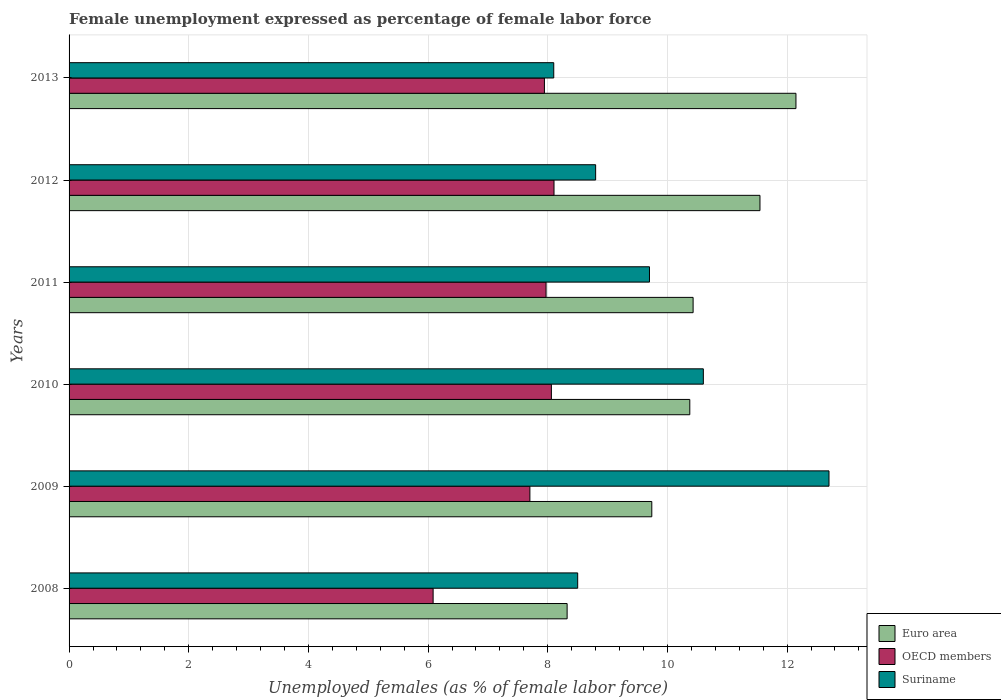Are the number of bars on each tick of the Y-axis equal?
Provide a short and direct response. Yes. How many bars are there on the 3rd tick from the top?
Give a very brief answer. 3. How many bars are there on the 2nd tick from the bottom?
Provide a short and direct response. 3. What is the unemployment in females in in Suriname in 2010?
Your answer should be very brief. 10.6. Across all years, what is the maximum unemployment in females in in OECD members?
Offer a very short reply. 8.1. Across all years, what is the minimum unemployment in females in in Euro area?
Ensure brevity in your answer.  8.32. In which year was the unemployment in females in in Euro area maximum?
Offer a very short reply. 2013. In which year was the unemployment in females in in OECD members minimum?
Keep it short and to the point. 2008. What is the total unemployment in females in in OECD members in the graph?
Offer a terse response. 45.87. What is the difference between the unemployment in females in in Suriname in 2010 and that in 2011?
Keep it short and to the point. 0.9. What is the difference between the unemployment in females in in Suriname in 2010 and the unemployment in females in in OECD members in 2011?
Keep it short and to the point. 2.63. What is the average unemployment in females in in Euro area per year?
Offer a terse response. 10.43. In the year 2008, what is the difference between the unemployment in females in in OECD members and unemployment in females in in Suriname?
Offer a terse response. -2.42. What is the ratio of the unemployment in females in in Euro area in 2011 to that in 2013?
Provide a succinct answer. 0.86. Is the unemployment in females in in Suriname in 2009 less than that in 2010?
Keep it short and to the point. No. What is the difference between the highest and the second highest unemployment in females in in OECD members?
Your answer should be very brief. 0.04. What is the difference between the highest and the lowest unemployment in females in in OECD members?
Keep it short and to the point. 2.02. What does the 1st bar from the top in 2008 represents?
Ensure brevity in your answer.  Suriname. Is it the case that in every year, the sum of the unemployment in females in in Suriname and unemployment in females in in OECD members is greater than the unemployment in females in in Euro area?
Offer a terse response. Yes. Are all the bars in the graph horizontal?
Give a very brief answer. Yes. How many years are there in the graph?
Your response must be concise. 6. Are the values on the major ticks of X-axis written in scientific E-notation?
Make the answer very short. No. Does the graph contain any zero values?
Give a very brief answer. No. How many legend labels are there?
Provide a succinct answer. 3. How are the legend labels stacked?
Make the answer very short. Vertical. What is the title of the graph?
Offer a very short reply. Female unemployment expressed as percentage of female labor force. What is the label or title of the X-axis?
Your response must be concise. Unemployed females (as % of female labor force). What is the Unemployed females (as % of female labor force) in Euro area in 2008?
Your answer should be compact. 8.32. What is the Unemployed females (as % of female labor force) of OECD members in 2008?
Give a very brief answer. 6.08. What is the Unemployed females (as % of female labor force) of Suriname in 2008?
Your answer should be very brief. 8.5. What is the Unemployed females (as % of female labor force) in Euro area in 2009?
Offer a very short reply. 9.74. What is the Unemployed females (as % of female labor force) in OECD members in 2009?
Ensure brevity in your answer.  7.7. What is the Unemployed females (as % of female labor force) of Suriname in 2009?
Your response must be concise. 12.7. What is the Unemployed females (as % of female labor force) in Euro area in 2010?
Offer a terse response. 10.37. What is the Unemployed females (as % of female labor force) in OECD members in 2010?
Your response must be concise. 8.06. What is the Unemployed females (as % of female labor force) of Suriname in 2010?
Offer a very short reply. 10.6. What is the Unemployed females (as % of female labor force) of Euro area in 2011?
Make the answer very short. 10.43. What is the Unemployed females (as % of female labor force) of OECD members in 2011?
Provide a short and direct response. 7.97. What is the Unemployed females (as % of female labor force) of Suriname in 2011?
Your answer should be very brief. 9.7. What is the Unemployed females (as % of female labor force) in Euro area in 2012?
Your answer should be very brief. 11.55. What is the Unemployed females (as % of female labor force) of OECD members in 2012?
Keep it short and to the point. 8.1. What is the Unemployed females (as % of female labor force) in Suriname in 2012?
Your response must be concise. 8.8. What is the Unemployed females (as % of female labor force) in Euro area in 2013?
Provide a succinct answer. 12.15. What is the Unemployed females (as % of female labor force) of OECD members in 2013?
Your response must be concise. 7.94. What is the Unemployed females (as % of female labor force) in Suriname in 2013?
Provide a short and direct response. 8.1. Across all years, what is the maximum Unemployed females (as % of female labor force) in Euro area?
Offer a very short reply. 12.15. Across all years, what is the maximum Unemployed females (as % of female labor force) of OECD members?
Make the answer very short. 8.1. Across all years, what is the maximum Unemployed females (as % of female labor force) of Suriname?
Your response must be concise. 12.7. Across all years, what is the minimum Unemployed females (as % of female labor force) of Euro area?
Ensure brevity in your answer.  8.32. Across all years, what is the minimum Unemployed females (as % of female labor force) in OECD members?
Your answer should be compact. 6.08. Across all years, what is the minimum Unemployed females (as % of female labor force) in Suriname?
Your answer should be compact. 8.1. What is the total Unemployed females (as % of female labor force) of Euro area in the graph?
Offer a terse response. 62.56. What is the total Unemployed females (as % of female labor force) in OECD members in the graph?
Offer a very short reply. 45.87. What is the total Unemployed females (as % of female labor force) in Suriname in the graph?
Offer a very short reply. 58.4. What is the difference between the Unemployed females (as % of female labor force) in Euro area in 2008 and that in 2009?
Provide a succinct answer. -1.42. What is the difference between the Unemployed females (as % of female labor force) in OECD members in 2008 and that in 2009?
Your answer should be compact. -1.62. What is the difference between the Unemployed females (as % of female labor force) of Suriname in 2008 and that in 2009?
Your response must be concise. -4.2. What is the difference between the Unemployed females (as % of female labor force) in Euro area in 2008 and that in 2010?
Provide a short and direct response. -2.05. What is the difference between the Unemployed females (as % of female labor force) in OECD members in 2008 and that in 2010?
Your response must be concise. -1.98. What is the difference between the Unemployed females (as % of female labor force) in Euro area in 2008 and that in 2011?
Offer a very short reply. -2.11. What is the difference between the Unemployed females (as % of female labor force) of OECD members in 2008 and that in 2011?
Your response must be concise. -1.89. What is the difference between the Unemployed females (as % of female labor force) in Suriname in 2008 and that in 2011?
Offer a very short reply. -1.2. What is the difference between the Unemployed females (as % of female labor force) of Euro area in 2008 and that in 2012?
Your response must be concise. -3.22. What is the difference between the Unemployed females (as % of female labor force) in OECD members in 2008 and that in 2012?
Offer a terse response. -2.02. What is the difference between the Unemployed females (as % of female labor force) in Suriname in 2008 and that in 2012?
Keep it short and to the point. -0.3. What is the difference between the Unemployed females (as % of female labor force) in Euro area in 2008 and that in 2013?
Offer a terse response. -3.82. What is the difference between the Unemployed females (as % of female labor force) in OECD members in 2008 and that in 2013?
Ensure brevity in your answer.  -1.86. What is the difference between the Unemployed females (as % of female labor force) in Suriname in 2008 and that in 2013?
Provide a short and direct response. 0.4. What is the difference between the Unemployed females (as % of female labor force) in Euro area in 2009 and that in 2010?
Provide a short and direct response. -0.63. What is the difference between the Unemployed females (as % of female labor force) in OECD members in 2009 and that in 2010?
Ensure brevity in your answer.  -0.36. What is the difference between the Unemployed females (as % of female labor force) in Euro area in 2009 and that in 2011?
Ensure brevity in your answer.  -0.69. What is the difference between the Unemployed females (as % of female labor force) in OECD members in 2009 and that in 2011?
Keep it short and to the point. -0.27. What is the difference between the Unemployed females (as % of female labor force) in Suriname in 2009 and that in 2011?
Keep it short and to the point. 3. What is the difference between the Unemployed females (as % of female labor force) of Euro area in 2009 and that in 2012?
Provide a short and direct response. -1.81. What is the difference between the Unemployed females (as % of female labor force) of OECD members in 2009 and that in 2012?
Your response must be concise. -0.4. What is the difference between the Unemployed females (as % of female labor force) of Euro area in 2009 and that in 2013?
Offer a very short reply. -2.41. What is the difference between the Unemployed females (as % of female labor force) in OECD members in 2009 and that in 2013?
Keep it short and to the point. -0.24. What is the difference between the Unemployed females (as % of female labor force) of Euro area in 2010 and that in 2011?
Offer a terse response. -0.06. What is the difference between the Unemployed females (as % of female labor force) of OECD members in 2010 and that in 2011?
Your answer should be compact. 0.09. What is the difference between the Unemployed females (as % of female labor force) in Euro area in 2010 and that in 2012?
Provide a short and direct response. -1.17. What is the difference between the Unemployed females (as % of female labor force) in OECD members in 2010 and that in 2012?
Give a very brief answer. -0.04. What is the difference between the Unemployed females (as % of female labor force) of Suriname in 2010 and that in 2012?
Ensure brevity in your answer.  1.8. What is the difference between the Unemployed females (as % of female labor force) of Euro area in 2010 and that in 2013?
Ensure brevity in your answer.  -1.77. What is the difference between the Unemployed females (as % of female labor force) in OECD members in 2010 and that in 2013?
Your response must be concise. 0.12. What is the difference between the Unemployed females (as % of female labor force) in Suriname in 2010 and that in 2013?
Keep it short and to the point. 2.5. What is the difference between the Unemployed females (as % of female labor force) of Euro area in 2011 and that in 2012?
Offer a very short reply. -1.12. What is the difference between the Unemployed females (as % of female labor force) of OECD members in 2011 and that in 2012?
Your response must be concise. -0.13. What is the difference between the Unemployed females (as % of female labor force) in Suriname in 2011 and that in 2012?
Provide a succinct answer. 0.9. What is the difference between the Unemployed females (as % of female labor force) of Euro area in 2011 and that in 2013?
Make the answer very short. -1.72. What is the difference between the Unemployed females (as % of female labor force) of OECD members in 2011 and that in 2013?
Make the answer very short. 0.03. What is the difference between the Unemployed females (as % of female labor force) in Euro area in 2012 and that in 2013?
Keep it short and to the point. -0.6. What is the difference between the Unemployed females (as % of female labor force) of OECD members in 2012 and that in 2013?
Make the answer very short. 0.16. What is the difference between the Unemployed females (as % of female labor force) in Euro area in 2008 and the Unemployed females (as % of female labor force) in OECD members in 2009?
Provide a succinct answer. 0.62. What is the difference between the Unemployed females (as % of female labor force) of Euro area in 2008 and the Unemployed females (as % of female labor force) of Suriname in 2009?
Your answer should be very brief. -4.38. What is the difference between the Unemployed females (as % of female labor force) in OECD members in 2008 and the Unemployed females (as % of female labor force) in Suriname in 2009?
Ensure brevity in your answer.  -6.62. What is the difference between the Unemployed females (as % of female labor force) in Euro area in 2008 and the Unemployed females (as % of female labor force) in OECD members in 2010?
Keep it short and to the point. 0.26. What is the difference between the Unemployed females (as % of female labor force) in Euro area in 2008 and the Unemployed females (as % of female labor force) in Suriname in 2010?
Your answer should be very brief. -2.28. What is the difference between the Unemployed females (as % of female labor force) of OECD members in 2008 and the Unemployed females (as % of female labor force) of Suriname in 2010?
Provide a succinct answer. -4.52. What is the difference between the Unemployed females (as % of female labor force) of Euro area in 2008 and the Unemployed females (as % of female labor force) of OECD members in 2011?
Offer a very short reply. 0.35. What is the difference between the Unemployed females (as % of female labor force) of Euro area in 2008 and the Unemployed females (as % of female labor force) of Suriname in 2011?
Provide a short and direct response. -1.38. What is the difference between the Unemployed females (as % of female labor force) in OECD members in 2008 and the Unemployed females (as % of female labor force) in Suriname in 2011?
Ensure brevity in your answer.  -3.62. What is the difference between the Unemployed females (as % of female labor force) in Euro area in 2008 and the Unemployed females (as % of female labor force) in OECD members in 2012?
Your answer should be very brief. 0.22. What is the difference between the Unemployed females (as % of female labor force) in Euro area in 2008 and the Unemployed females (as % of female labor force) in Suriname in 2012?
Offer a very short reply. -0.48. What is the difference between the Unemployed females (as % of female labor force) in OECD members in 2008 and the Unemployed females (as % of female labor force) in Suriname in 2012?
Provide a succinct answer. -2.72. What is the difference between the Unemployed females (as % of female labor force) in Euro area in 2008 and the Unemployed females (as % of female labor force) in OECD members in 2013?
Your response must be concise. 0.38. What is the difference between the Unemployed females (as % of female labor force) of Euro area in 2008 and the Unemployed females (as % of female labor force) of Suriname in 2013?
Offer a very short reply. 0.22. What is the difference between the Unemployed females (as % of female labor force) of OECD members in 2008 and the Unemployed females (as % of female labor force) of Suriname in 2013?
Offer a terse response. -2.02. What is the difference between the Unemployed females (as % of female labor force) in Euro area in 2009 and the Unemployed females (as % of female labor force) in OECD members in 2010?
Offer a terse response. 1.68. What is the difference between the Unemployed females (as % of female labor force) of Euro area in 2009 and the Unemployed females (as % of female labor force) of Suriname in 2010?
Your answer should be very brief. -0.86. What is the difference between the Unemployed females (as % of female labor force) of OECD members in 2009 and the Unemployed females (as % of female labor force) of Suriname in 2010?
Offer a very short reply. -2.9. What is the difference between the Unemployed females (as % of female labor force) in Euro area in 2009 and the Unemployed females (as % of female labor force) in OECD members in 2011?
Give a very brief answer. 1.77. What is the difference between the Unemployed females (as % of female labor force) of Euro area in 2009 and the Unemployed females (as % of female labor force) of Suriname in 2011?
Provide a short and direct response. 0.04. What is the difference between the Unemployed females (as % of female labor force) in OECD members in 2009 and the Unemployed females (as % of female labor force) in Suriname in 2011?
Provide a short and direct response. -2. What is the difference between the Unemployed females (as % of female labor force) of Euro area in 2009 and the Unemployed females (as % of female labor force) of OECD members in 2012?
Ensure brevity in your answer.  1.63. What is the difference between the Unemployed females (as % of female labor force) of Euro area in 2009 and the Unemployed females (as % of female labor force) of Suriname in 2012?
Keep it short and to the point. 0.94. What is the difference between the Unemployed females (as % of female labor force) in OECD members in 2009 and the Unemployed females (as % of female labor force) in Suriname in 2012?
Ensure brevity in your answer.  -1.1. What is the difference between the Unemployed females (as % of female labor force) of Euro area in 2009 and the Unemployed females (as % of female labor force) of OECD members in 2013?
Provide a succinct answer. 1.79. What is the difference between the Unemployed females (as % of female labor force) of Euro area in 2009 and the Unemployed females (as % of female labor force) of Suriname in 2013?
Provide a short and direct response. 1.64. What is the difference between the Unemployed females (as % of female labor force) of OECD members in 2009 and the Unemployed females (as % of female labor force) of Suriname in 2013?
Give a very brief answer. -0.4. What is the difference between the Unemployed females (as % of female labor force) in Euro area in 2010 and the Unemployed females (as % of female labor force) in OECD members in 2011?
Your response must be concise. 2.4. What is the difference between the Unemployed females (as % of female labor force) in Euro area in 2010 and the Unemployed females (as % of female labor force) in Suriname in 2011?
Offer a terse response. 0.67. What is the difference between the Unemployed females (as % of female labor force) of OECD members in 2010 and the Unemployed females (as % of female labor force) of Suriname in 2011?
Offer a very short reply. -1.64. What is the difference between the Unemployed females (as % of female labor force) of Euro area in 2010 and the Unemployed females (as % of female labor force) of OECD members in 2012?
Keep it short and to the point. 2.27. What is the difference between the Unemployed females (as % of female labor force) in Euro area in 2010 and the Unemployed females (as % of female labor force) in Suriname in 2012?
Your answer should be very brief. 1.57. What is the difference between the Unemployed females (as % of female labor force) of OECD members in 2010 and the Unemployed females (as % of female labor force) of Suriname in 2012?
Offer a very short reply. -0.74. What is the difference between the Unemployed females (as % of female labor force) in Euro area in 2010 and the Unemployed females (as % of female labor force) in OECD members in 2013?
Ensure brevity in your answer.  2.43. What is the difference between the Unemployed females (as % of female labor force) of Euro area in 2010 and the Unemployed females (as % of female labor force) of Suriname in 2013?
Your answer should be very brief. 2.27. What is the difference between the Unemployed females (as % of female labor force) in OECD members in 2010 and the Unemployed females (as % of female labor force) in Suriname in 2013?
Offer a very short reply. -0.04. What is the difference between the Unemployed females (as % of female labor force) of Euro area in 2011 and the Unemployed females (as % of female labor force) of OECD members in 2012?
Your answer should be compact. 2.32. What is the difference between the Unemployed females (as % of female labor force) of Euro area in 2011 and the Unemployed females (as % of female labor force) of Suriname in 2012?
Your answer should be compact. 1.63. What is the difference between the Unemployed females (as % of female labor force) of OECD members in 2011 and the Unemployed females (as % of female labor force) of Suriname in 2012?
Your answer should be compact. -0.83. What is the difference between the Unemployed females (as % of female labor force) in Euro area in 2011 and the Unemployed females (as % of female labor force) in OECD members in 2013?
Make the answer very short. 2.48. What is the difference between the Unemployed females (as % of female labor force) of Euro area in 2011 and the Unemployed females (as % of female labor force) of Suriname in 2013?
Your answer should be compact. 2.33. What is the difference between the Unemployed females (as % of female labor force) in OECD members in 2011 and the Unemployed females (as % of female labor force) in Suriname in 2013?
Keep it short and to the point. -0.13. What is the difference between the Unemployed females (as % of female labor force) of Euro area in 2012 and the Unemployed females (as % of female labor force) of OECD members in 2013?
Your answer should be compact. 3.6. What is the difference between the Unemployed females (as % of female labor force) in Euro area in 2012 and the Unemployed females (as % of female labor force) in Suriname in 2013?
Your response must be concise. 3.45. What is the difference between the Unemployed females (as % of female labor force) of OECD members in 2012 and the Unemployed females (as % of female labor force) of Suriname in 2013?
Offer a very short reply. 0. What is the average Unemployed females (as % of female labor force) of Euro area per year?
Offer a terse response. 10.43. What is the average Unemployed females (as % of female labor force) of OECD members per year?
Offer a very short reply. 7.64. What is the average Unemployed females (as % of female labor force) in Suriname per year?
Make the answer very short. 9.73. In the year 2008, what is the difference between the Unemployed females (as % of female labor force) of Euro area and Unemployed females (as % of female labor force) of OECD members?
Give a very brief answer. 2.24. In the year 2008, what is the difference between the Unemployed females (as % of female labor force) of Euro area and Unemployed females (as % of female labor force) of Suriname?
Offer a terse response. -0.18. In the year 2008, what is the difference between the Unemployed females (as % of female labor force) in OECD members and Unemployed females (as % of female labor force) in Suriname?
Offer a very short reply. -2.42. In the year 2009, what is the difference between the Unemployed females (as % of female labor force) of Euro area and Unemployed females (as % of female labor force) of OECD members?
Your answer should be very brief. 2.04. In the year 2009, what is the difference between the Unemployed females (as % of female labor force) of Euro area and Unemployed females (as % of female labor force) of Suriname?
Give a very brief answer. -2.96. In the year 2009, what is the difference between the Unemployed females (as % of female labor force) of OECD members and Unemployed females (as % of female labor force) of Suriname?
Your answer should be compact. -5. In the year 2010, what is the difference between the Unemployed females (as % of female labor force) of Euro area and Unemployed females (as % of female labor force) of OECD members?
Offer a terse response. 2.31. In the year 2010, what is the difference between the Unemployed females (as % of female labor force) in Euro area and Unemployed females (as % of female labor force) in Suriname?
Provide a succinct answer. -0.23. In the year 2010, what is the difference between the Unemployed females (as % of female labor force) of OECD members and Unemployed females (as % of female labor force) of Suriname?
Ensure brevity in your answer.  -2.54. In the year 2011, what is the difference between the Unemployed females (as % of female labor force) of Euro area and Unemployed females (as % of female labor force) of OECD members?
Offer a very short reply. 2.46. In the year 2011, what is the difference between the Unemployed females (as % of female labor force) of Euro area and Unemployed females (as % of female labor force) of Suriname?
Make the answer very short. 0.73. In the year 2011, what is the difference between the Unemployed females (as % of female labor force) in OECD members and Unemployed females (as % of female labor force) in Suriname?
Provide a short and direct response. -1.73. In the year 2012, what is the difference between the Unemployed females (as % of female labor force) in Euro area and Unemployed females (as % of female labor force) in OECD members?
Keep it short and to the point. 3.44. In the year 2012, what is the difference between the Unemployed females (as % of female labor force) in Euro area and Unemployed females (as % of female labor force) in Suriname?
Provide a succinct answer. 2.75. In the year 2012, what is the difference between the Unemployed females (as % of female labor force) of OECD members and Unemployed females (as % of female labor force) of Suriname?
Ensure brevity in your answer.  -0.7. In the year 2013, what is the difference between the Unemployed females (as % of female labor force) in Euro area and Unemployed females (as % of female labor force) in OECD members?
Offer a terse response. 4.2. In the year 2013, what is the difference between the Unemployed females (as % of female labor force) in Euro area and Unemployed females (as % of female labor force) in Suriname?
Your answer should be compact. 4.05. In the year 2013, what is the difference between the Unemployed females (as % of female labor force) of OECD members and Unemployed females (as % of female labor force) of Suriname?
Ensure brevity in your answer.  -0.16. What is the ratio of the Unemployed females (as % of female labor force) of Euro area in 2008 to that in 2009?
Ensure brevity in your answer.  0.85. What is the ratio of the Unemployed females (as % of female labor force) of OECD members in 2008 to that in 2009?
Make the answer very short. 0.79. What is the ratio of the Unemployed females (as % of female labor force) in Suriname in 2008 to that in 2009?
Your answer should be very brief. 0.67. What is the ratio of the Unemployed females (as % of female labor force) in Euro area in 2008 to that in 2010?
Give a very brief answer. 0.8. What is the ratio of the Unemployed females (as % of female labor force) in OECD members in 2008 to that in 2010?
Ensure brevity in your answer.  0.75. What is the ratio of the Unemployed females (as % of female labor force) in Suriname in 2008 to that in 2010?
Keep it short and to the point. 0.8. What is the ratio of the Unemployed females (as % of female labor force) in Euro area in 2008 to that in 2011?
Give a very brief answer. 0.8. What is the ratio of the Unemployed females (as % of female labor force) of OECD members in 2008 to that in 2011?
Offer a very short reply. 0.76. What is the ratio of the Unemployed females (as % of female labor force) of Suriname in 2008 to that in 2011?
Ensure brevity in your answer.  0.88. What is the ratio of the Unemployed females (as % of female labor force) in Euro area in 2008 to that in 2012?
Provide a short and direct response. 0.72. What is the ratio of the Unemployed females (as % of female labor force) of OECD members in 2008 to that in 2012?
Ensure brevity in your answer.  0.75. What is the ratio of the Unemployed females (as % of female labor force) in Suriname in 2008 to that in 2012?
Keep it short and to the point. 0.97. What is the ratio of the Unemployed females (as % of female labor force) in Euro area in 2008 to that in 2013?
Give a very brief answer. 0.69. What is the ratio of the Unemployed females (as % of female labor force) of OECD members in 2008 to that in 2013?
Your response must be concise. 0.77. What is the ratio of the Unemployed females (as % of female labor force) of Suriname in 2008 to that in 2013?
Your answer should be very brief. 1.05. What is the ratio of the Unemployed females (as % of female labor force) in Euro area in 2009 to that in 2010?
Offer a terse response. 0.94. What is the ratio of the Unemployed females (as % of female labor force) in OECD members in 2009 to that in 2010?
Ensure brevity in your answer.  0.96. What is the ratio of the Unemployed females (as % of female labor force) in Suriname in 2009 to that in 2010?
Make the answer very short. 1.2. What is the ratio of the Unemployed females (as % of female labor force) in Euro area in 2009 to that in 2011?
Your answer should be very brief. 0.93. What is the ratio of the Unemployed females (as % of female labor force) of OECD members in 2009 to that in 2011?
Your response must be concise. 0.97. What is the ratio of the Unemployed females (as % of female labor force) of Suriname in 2009 to that in 2011?
Keep it short and to the point. 1.31. What is the ratio of the Unemployed females (as % of female labor force) in Euro area in 2009 to that in 2012?
Make the answer very short. 0.84. What is the ratio of the Unemployed females (as % of female labor force) in OECD members in 2009 to that in 2012?
Provide a succinct answer. 0.95. What is the ratio of the Unemployed females (as % of female labor force) in Suriname in 2009 to that in 2012?
Give a very brief answer. 1.44. What is the ratio of the Unemployed females (as % of female labor force) in Euro area in 2009 to that in 2013?
Offer a terse response. 0.8. What is the ratio of the Unemployed females (as % of female labor force) in OECD members in 2009 to that in 2013?
Your response must be concise. 0.97. What is the ratio of the Unemployed females (as % of female labor force) in Suriname in 2009 to that in 2013?
Offer a terse response. 1.57. What is the ratio of the Unemployed females (as % of female labor force) in OECD members in 2010 to that in 2011?
Offer a very short reply. 1.01. What is the ratio of the Unemployed females (as % of female labor force) of Suriname in 2010 to that in 2011?
Offer a terse response. 1.09. What is the ratio of the Unemployed females (as % of female labor force) of Euro area in 2010 to that in 2012?
Keep it short and to the point. 0.9. What is the ratio of the Unemployed females (as % of female labor force) in OECD members in 2010 to that in 2012?
Give a very brief answer. 0.99. What is the ratio of the Unemployed females (as % of female labor force) in Suriname in 2010 to that in 2012?
Offer a terse response. 1.2. What is the ratio of the Unemployed females (as % of female labor force) of Euro area in 2010 to that in 2013?
Provide a short and direct response. 0.85. What is the ratio of the Unemployed females (as % of female labor force) in OECD members in 2010 to that in 2013?
Ensure brevity in your answer.  1.01. What is the ratio of the Unemployed females (as % of female labor force) of Suriname in 2010 to that in 2013?
Your answer should be compact. 1.31. What is the ratio of the Unemployed females (as % of female labor force) in Euro area in 2011 to that in 2012?
Offer a very short reply. 0.9. What is the ratio of the Unemployed females (as % of female labor force) in OECD members in 2011 to that in 2012?
Give a very brief answer. 0.98. What is the ratio of the Unemployed females (as % of female labor force) of Suriname in 2011 to that in 2012?
Your answer should be compact. 1.1. What is the ratio of the Unemployed females (as % of female labor force) in Euro area in 2011 to that in 2013?
Provide a short and direct response. 0.86. What is the ratio of the Unemployed females (as % of female labor force) of OECD members in 2011 to that in 2013?
Your answer should be very brief. 1. What is the ratio of the Unemployed females (as % of female labor force) of Suriname in 2011 to that in 2013?
Provide a short and direct response. 1.2. What is the ratio of the Unemployed females (as % of female labor force) in Euro area in 2012 to that in 2013?
Keep it short and to the point. 0.95. What is the ratio of the Unemployed females (as % of female labor force) of OECD members in 2012 to that in 2013?
Your response must be concise. 1.02. What is the ratio of the Unemployed females (as % of female labor force) in Suriname in 2012 to that in 2013?
Ensure brevity in your answer.  1.09. What is the difference between the highest and the second highest Unemployed females (as % of female labor force) of Euro area?
Provide a short and direct response. 0.6. What is the difference between the highest and the second highest Unemployed females (as % of female labor force) in OECD members?
Your answer should be very brief. 0.04. What is the difference between the highest and the second highest Unemployed females (as % of female labor force) of Suriname?
Ensure brevity in your answer.  2.1. What is the difference between the highest and the lowest Unemployed females (as % of female labor force) of Euro area?
Your response must be concise. 3.82. What is the difference between the highest and the lowest Unemployed females (as % of female labor force) of OECD members?
Your answer should be very brief. 2.02. What is the difference between the highest and the lowest Unemployed females (as % of female labor force) in Suriname?
Your answer should be very brief. 4.6. 